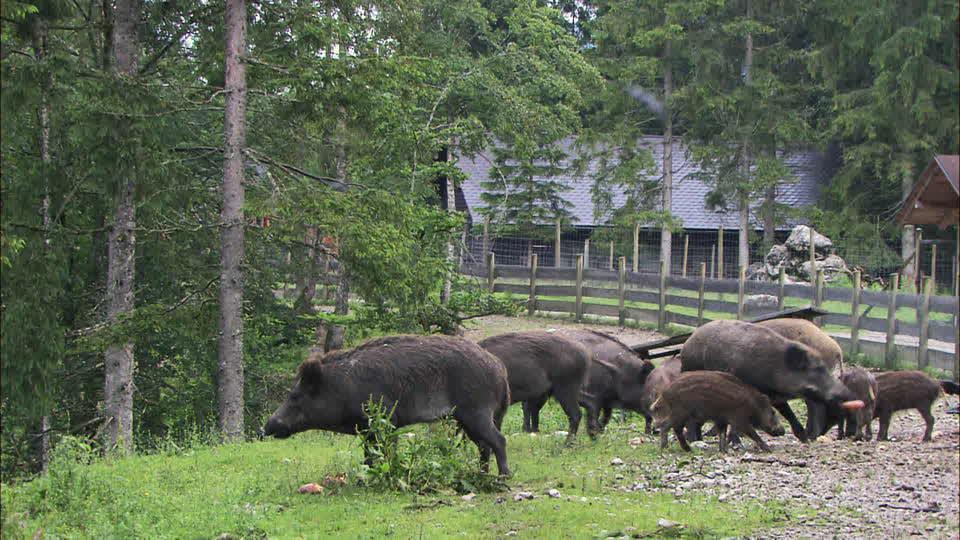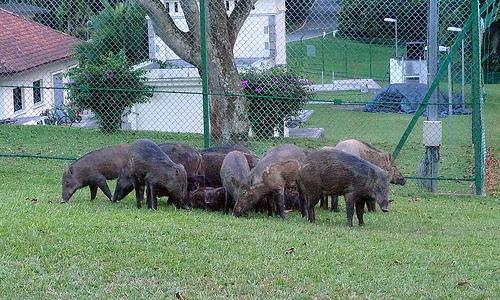The first image is the image on the left, the second image is the image on the right. Given the left and right images, does the statement "The right image contains exactly two boars." hold true? Answer yes or no. No. 